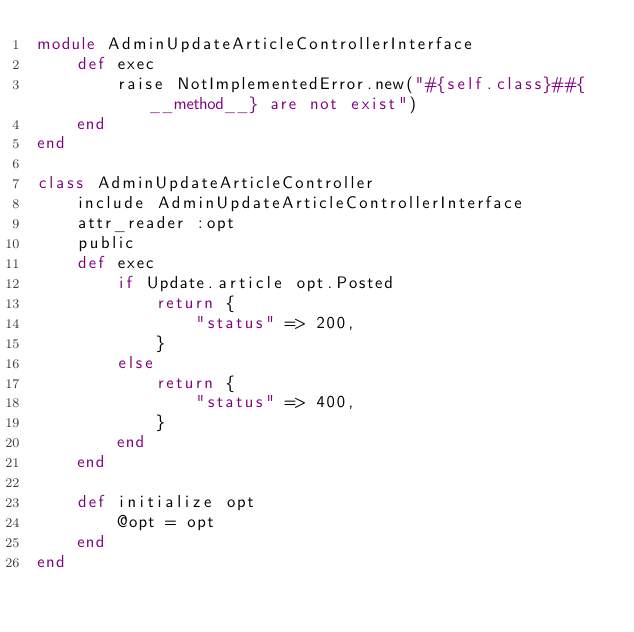Convert code to text. <code><loc_0><loc_0><loc_500><loc_500><_Ruby_>module AdminUpdateArticleControllerInterface
    def exec
        raise NotImplementedError.new("#{self.class}##{__method__} are not exist")
    end
end

class AdminUpdateArticleController
    include AdminUpdateArticleControllerInterface
    attr_reader :opt
    public
    def exec
        if Update.article opt.Posted
            return {
                "status" => 200,
            }
        else
            return {
                "status" => 400,
            }
        end
    end

    def initialize opt
        @opt = opt
    end
end
</code> 